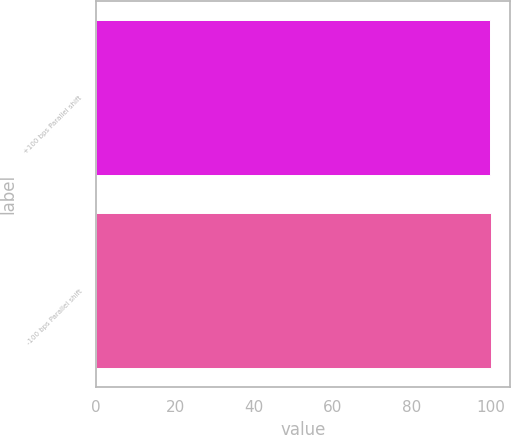Convert chart. <chart><loc_0><loc_0><loc_500><loc_500><bar_chart><fcel>+100 bps Parallel shift<fcel>-100 bps Parallel shift<nl><fcel>100<fcel>100.1<nl></chart> 